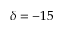Convert formula to latex. <formula><loc_0><loc_0><loc_500><loc_500>\delta = - 1 5</formula> 